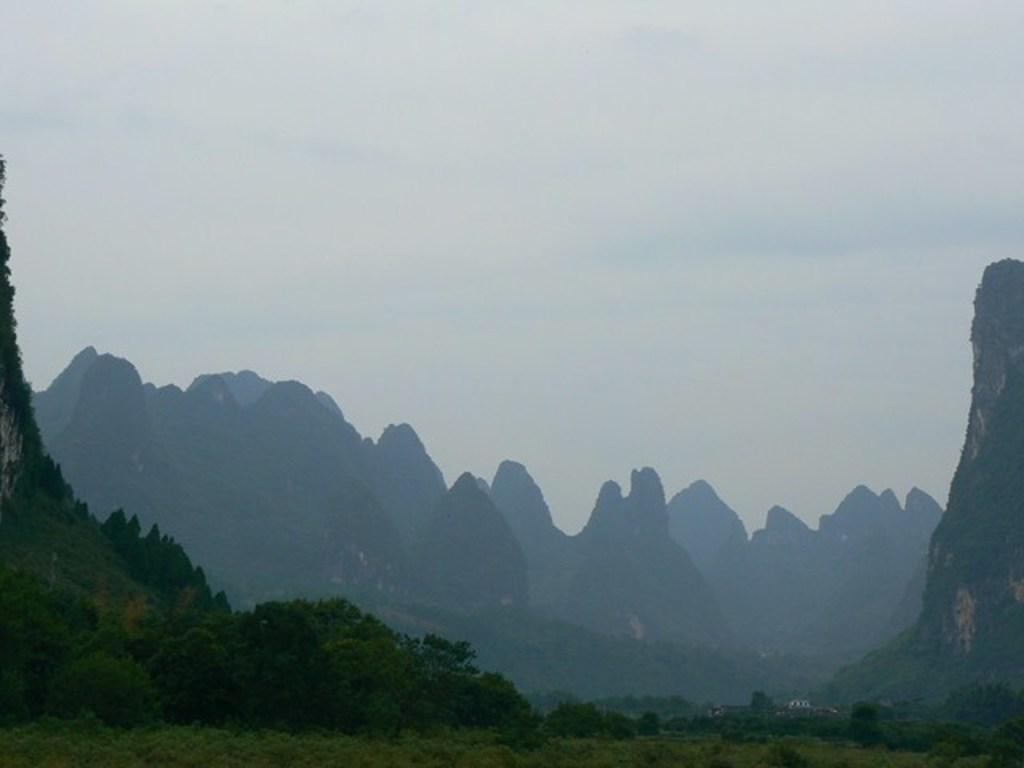What type of landscape is depicted in the image? The image features hills. What can be found on the hills? The hills have trees on them. What part of the natural environment is visible in the image? The sky is visible in the image. What is the condition of the sky in the image? There are clouds in the sky. Where is the chair located in the image? There is no chair present in the image. What type of heat source can be seen in the image? There is no heat source visible in the image. 